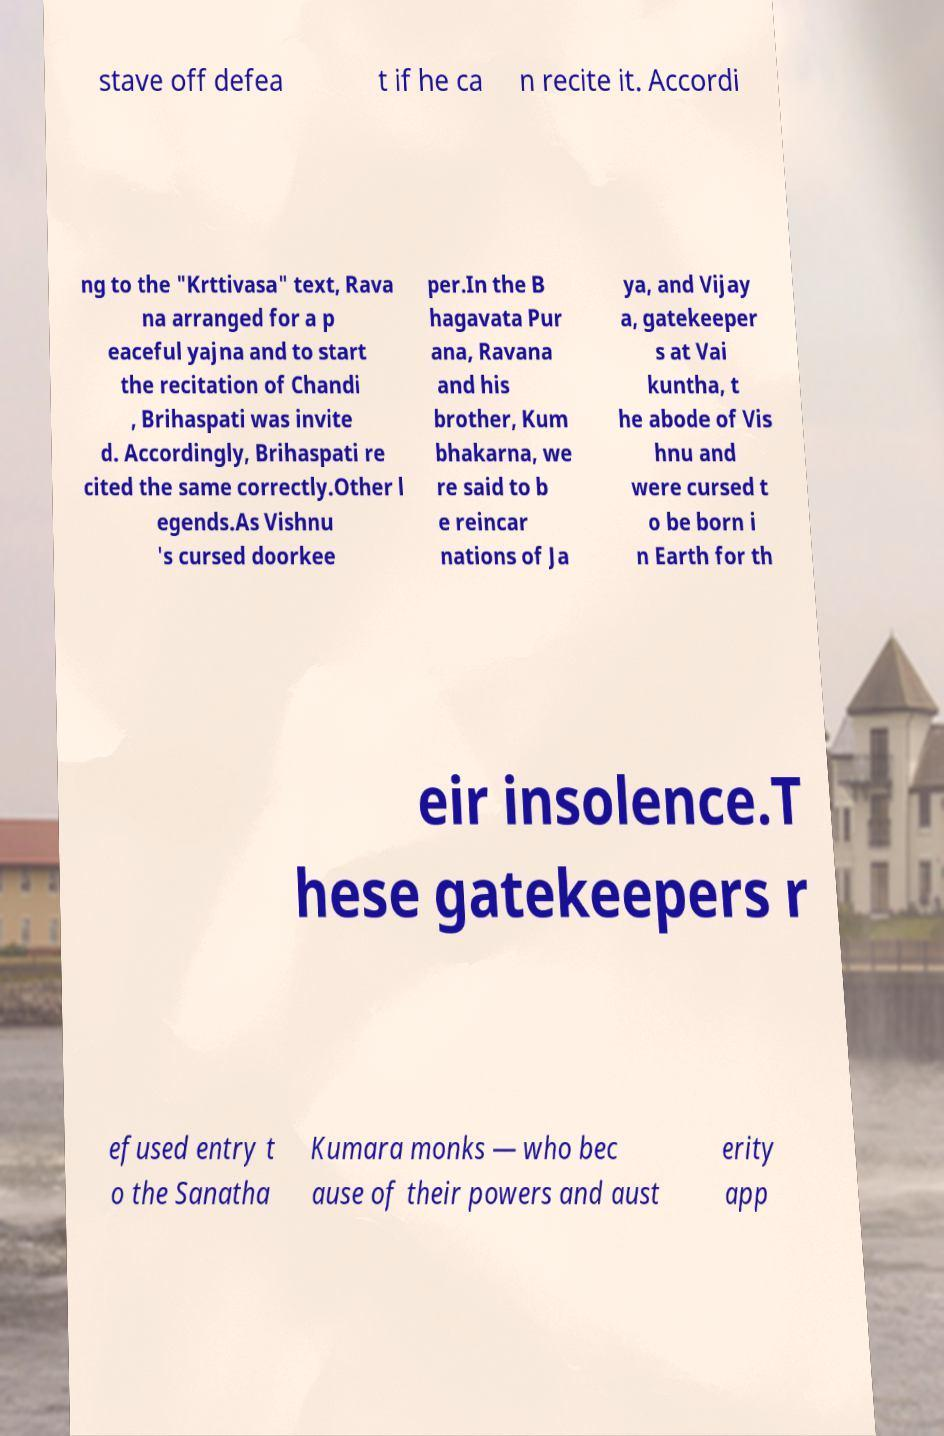Please identify and transcribe the text found in this image. stave off defea t if he ca n recite it. Accordi ng to the "Krttivasa" text, Rava na arranged for a p eaceful yajna and to start the recitation of Chandi , Brihaspati was invite d. Accordingly, Brihaspati re cited the same correctly.Other l egends.As Vishnu 's cursed doorkee per.In the B hagavata Pur ana, Ravana and his brother, Kum bhakarna, we re said to b e reincar nations of Ja ya, and Vijay a, gatekeeper s at Vai kuntha, t he abode of Vis hnu and were cursed t o be born i n Earth for th eir insolence.T hese gatekeepers r efused entry t o the Sanatha Kumara monks — who bec ause of their powers and aust erity app 